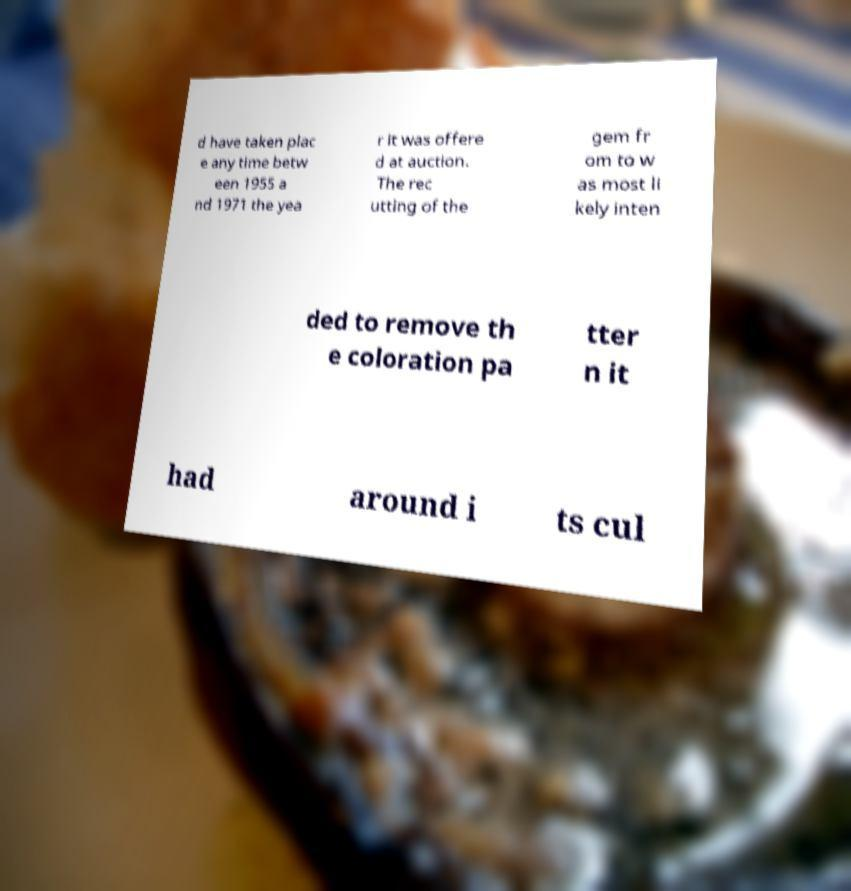There's text embedded in this image that I need extracted. Can you transcribe it verbatim? d have taken plac e any time betw een 1955 a nd 1971 the yea r it was offere d at auction. The rec utting of the gem fr om to w as most li kely inten ded to remove th e coloration pa tter n it had around i ts cul 